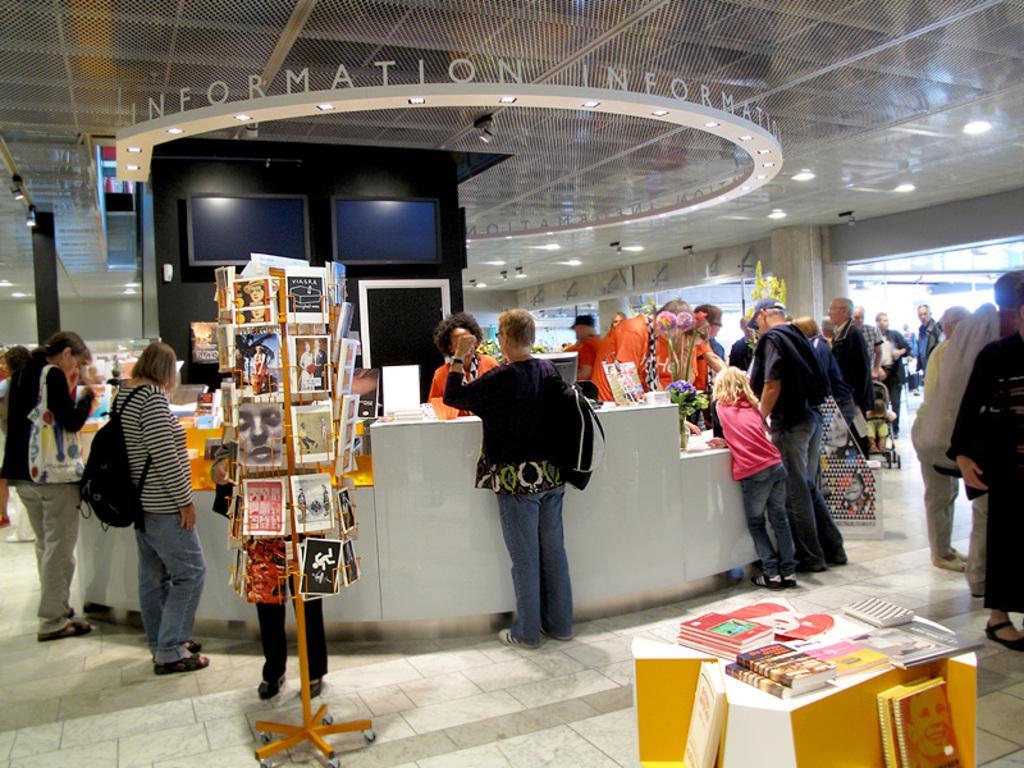Describe this image in one or two sentences. To this ceiling there are lights. Here we can see people, tables and books stand. To this book stand there are books. Above these tables there are books and things. Backside of this person there are screens on the black wall. This is tile floor. 